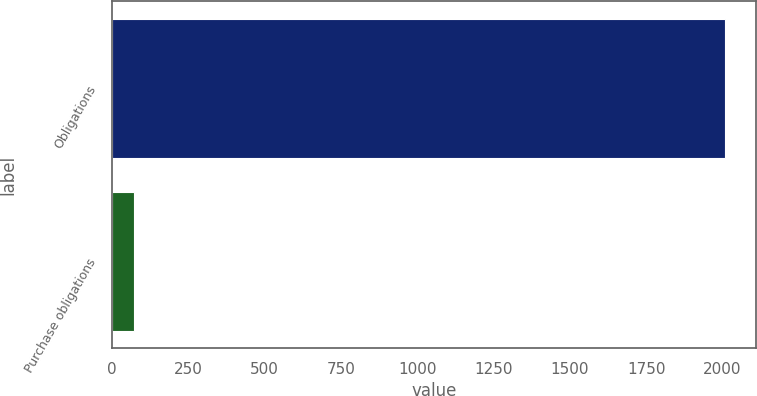Convert chart. <chart><loc_0><loc_0><loc_500><loc_500><bar_chart><fcel>Obligations<fcel>Purchase obligations<nl><fcel>2009<fcel>72.3<nl></chart> 